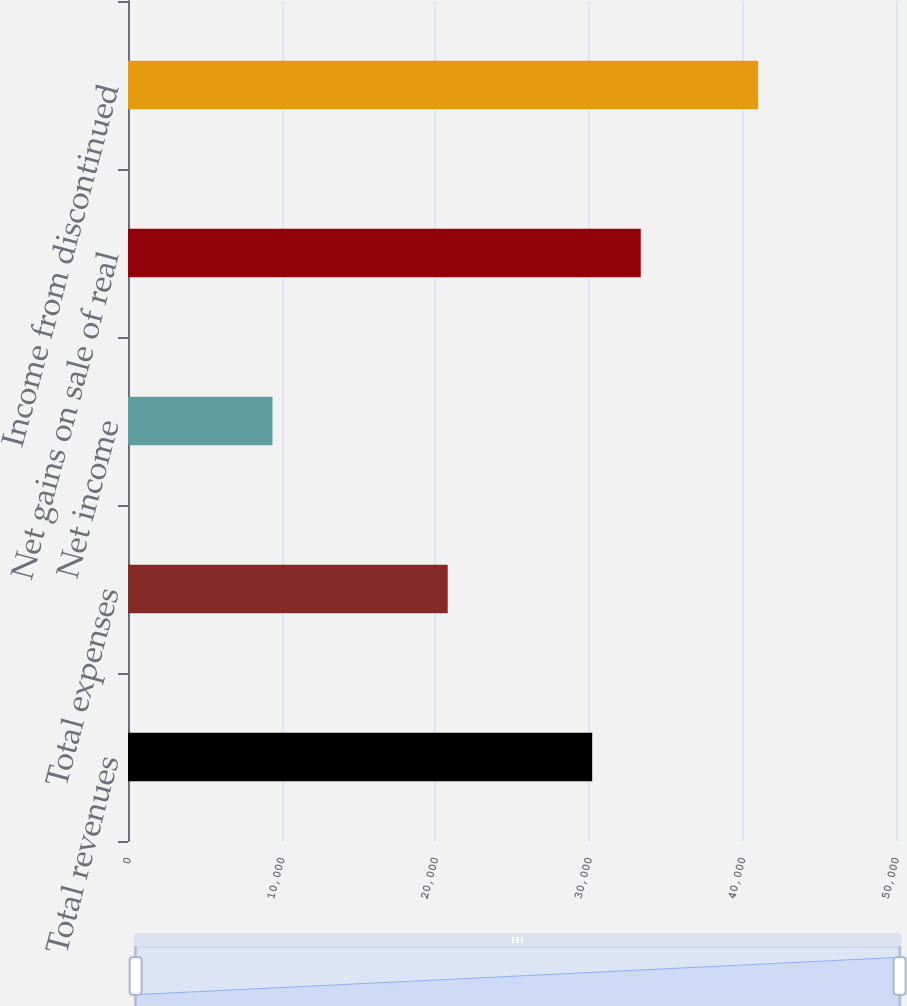Convert chart to OTSL. <chart><loc_0><loc_0><loc_500><loc_500><bar_chart><fcel>Total revenues<fcel>Total expenses<fcel>Net income<fcel>Net gains on sale of real<fcel>Income from discontinued<nl><fcel>30221<fcel>20815<fcel>9406<fcel>33382.4<fcel>41020<nl></chart> 